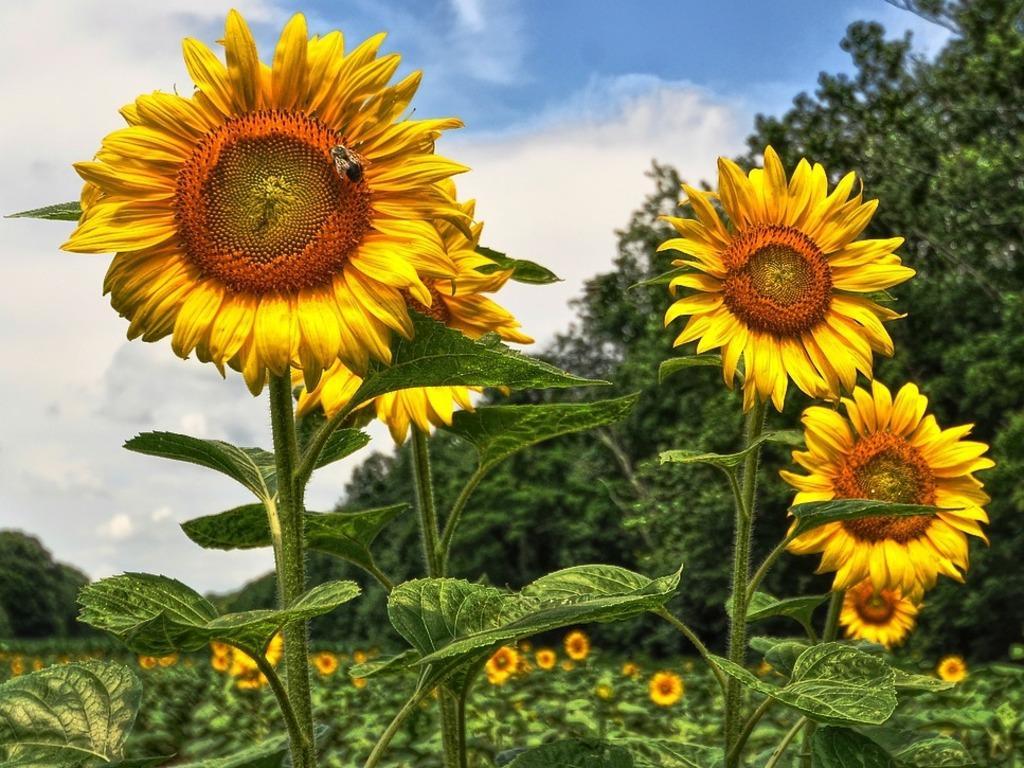Describe this image in one or two sentences. There are few sunflowers and there are trees in the background. 